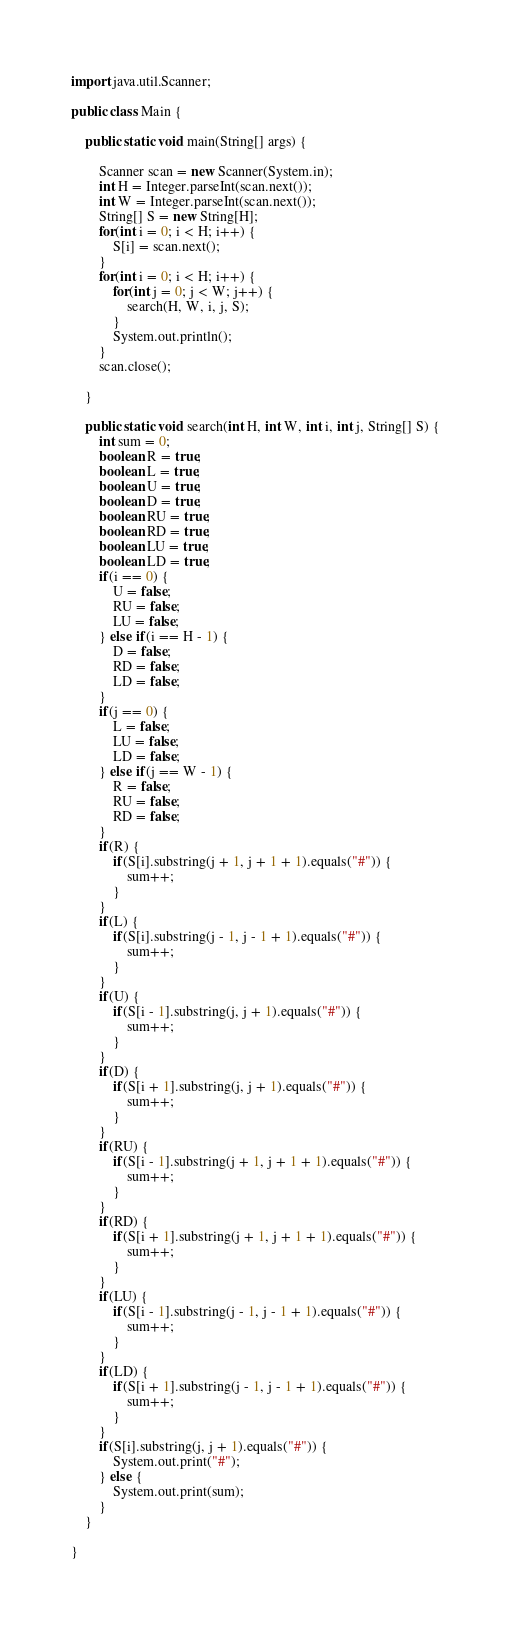Convert code to text. <code><loc_0><loc_0><loc_500><loc_500><_Java_>import java.util.Scanner;

public class Main {

	public static void main(String[] args) {
		
		Scanner scan = new Scanner(System.in);
		int H = Integer.parseInt(scan.next());
		int W = Integer.parseInt(scan.next());
		String[] S = new String[H];
		for(int i = 0; i < H; i++) {
			S[i] = scan.next();
		}
		for(int i = 0; i < H; i++) {
			for(int j = 0; j < W; j++) {
				search(H, W, i, j, S);
			}
			System.out.println();
		}
		scan.close();

	}
	
	public static void search(int H, int W, int i, int j, String[] S) {
		int sum = 0;
		boolean R = true;
		boolean L = true;
		boolean U = true;
		boolean D = true;
		boolean RU = true;
		boolean RD = true;
		boolean LU = true;
		boolean LD = true;
		if(i == 0) {
			U = false;
			RU = false;
			LU = false;
		} else if(i == H - 1) {
			D = false;
			RD = false;
			LD = false;
		}
		if(j == 0) {
			L = false;
			LU = false;
			LD = false;
		} else if(j == W - 1) {
			R = false;
			RU = false;
			RD = false;
		}
		if(R) {
			if(S[i].substring(j + 1, j + 1 + 1).equals("#")) {
				sum++;
			}
		}
		if(L) {
			if(S[i].substring(j - 1, j - 1 + 1).equals("#")) {
				sum++;
			}
		}
		if(U) {
			if(S[i - 1].substring(j, j + 1).equals("#")) {
				sum++;
			}
		}
		if(D) {
			if(S[i + 1].substring(j, j + 1).equals("#")) {
				sum++;
			}
		}
		if(RU) {
			if(S[i - 1].substring(j + 1, j + 1 + 1).equals("#")) {
				sum++;
			}
		}
		if(RD) {
			if(S[i + 1].substring(j + 1, j + 1 + 1).equals("#")) {
				sum++;
			}
		}
		if(LU) {
			if(S[i - 1].substring(j - 1, j - 1 + 1).equals("#")) {
				sum++;
			}
		}
		if(LD) {
			if(S[i + 1].substring(j - 1, j - 1 + 1).equals("#")) {
				sum++;
			}
		}
		if(S[i].substring(j, j + 1).equals("#")) {
			System.out.print("#");
		} else {
			System.out.print(sum);
		}
	}

}
</code> 